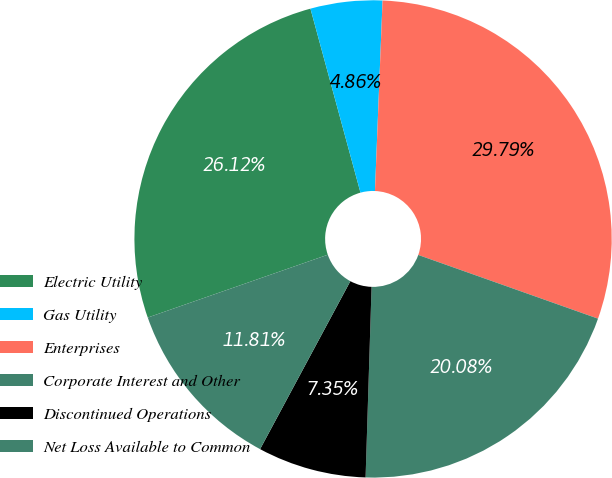Convert chart to OTSL. <chart><loc_0><loc_0><loc_500><loc_500><pie_chart><fcel>Electric Utility<fcel>Gas Utility<fcel>Enterprises<fcel>Corporate Interest and Other<fcel>Discontinued Operations<fcel>Net Loss Available to Common<nl><fcel>26.12%<fcel>4.86%<fcel>29.79%<fcel>20.08%<fcel>7.35%<fcel>11.81%<nl></chart> 